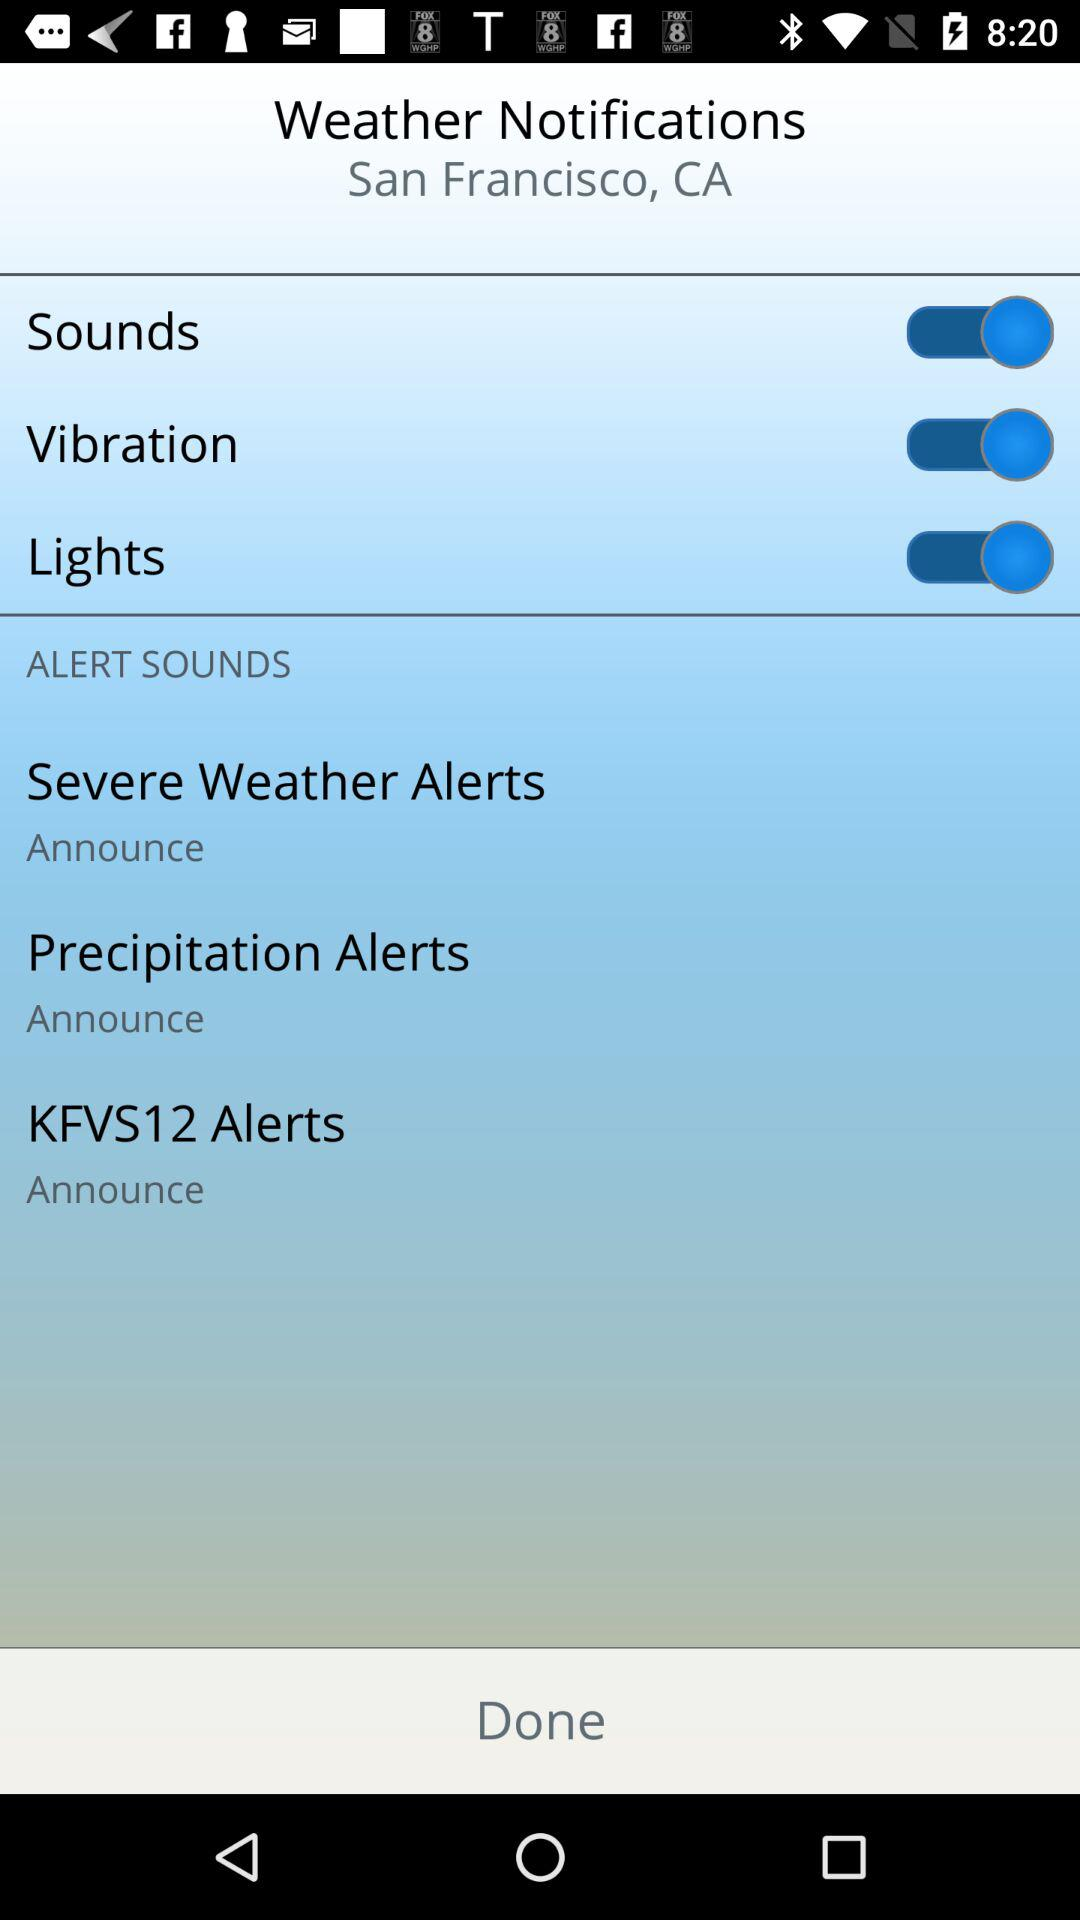What's the status of the "Sounds"? The status of the "Sounds" is "on". 